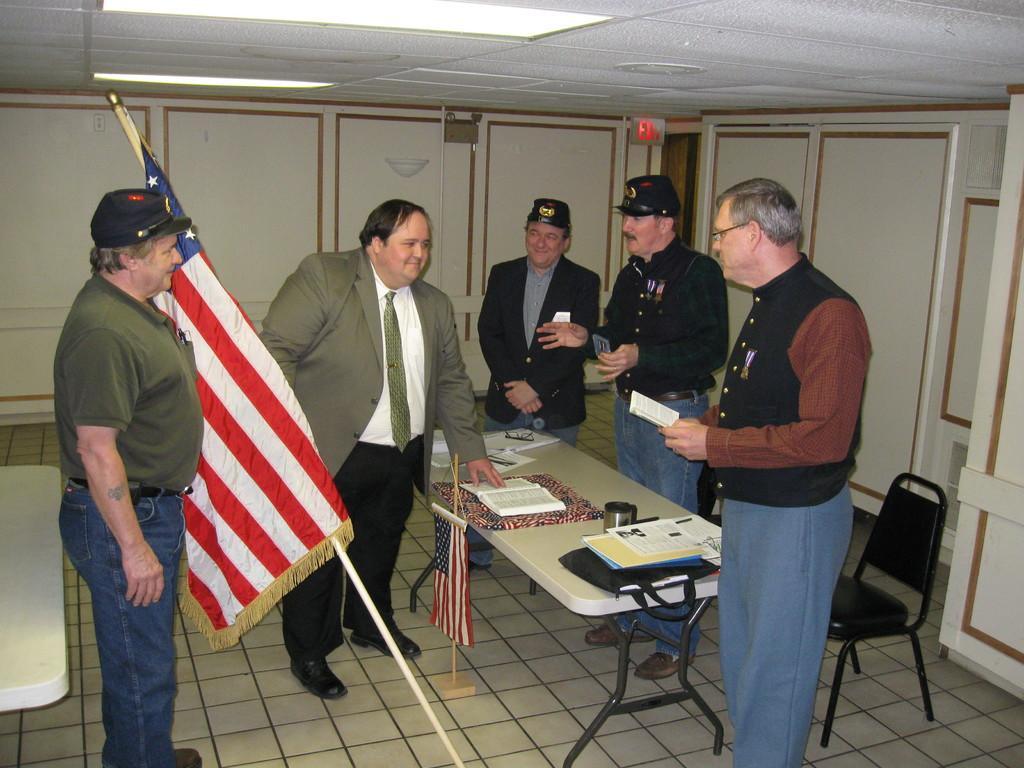Please provide a concise description of this image. In this image i can see few people standing around the table and a person on the left corner is holding a flag. In the background i can see the wall, a sign board, the door, few chairs and the ceiling. 